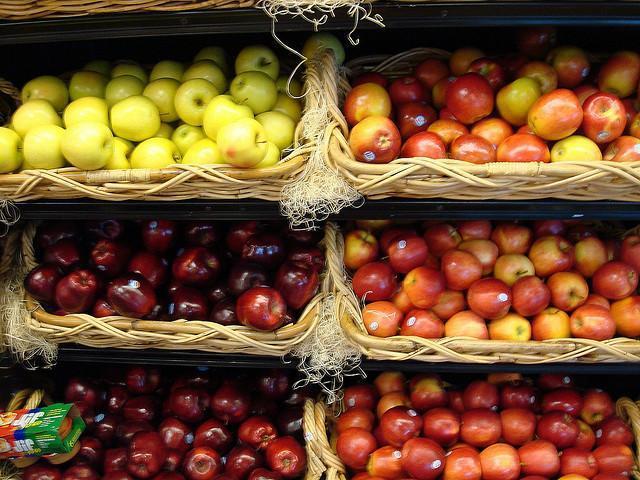How many different kinds of apples are there?
Give a very brief answer. 3. How many apples are there?
Give a very brief answer. 3. 